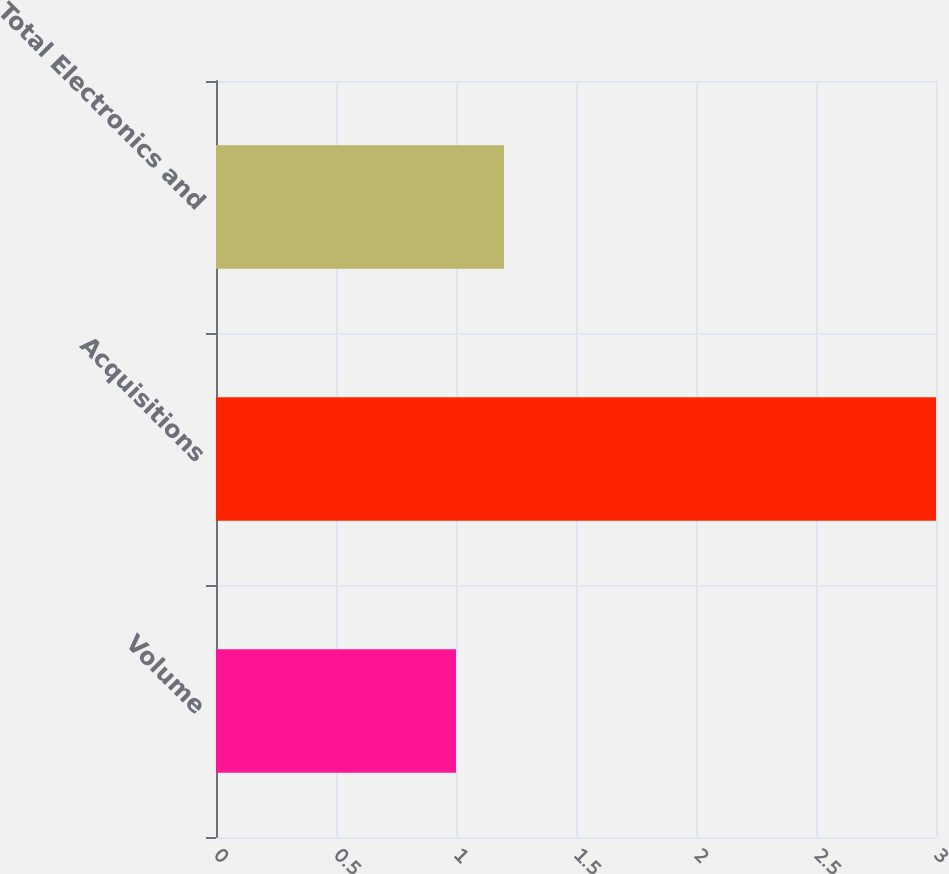Convert chart. <chart><loc_0><loc_0><loc_500><loc_500><bar_chart><fcel>Volume<fcel>Acquisitions<fcel>Total Electronics and<nl><fcel>1<fcel>3<fcel>1.2<nl></chart> 